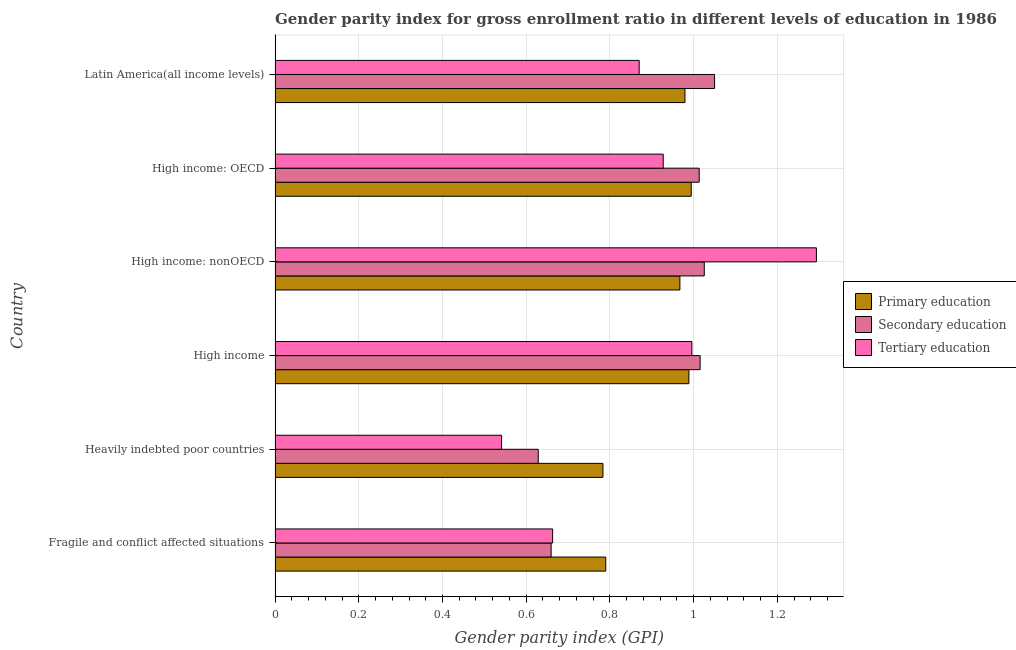How many different coloured bars are there?
Provide a short and direct response. 3. How many groups of bars are there?
Keep it short and to the point. 6. Are the number of bars on each tick of the Y-axis equal?
Offer a very short reply. Yes. What is the label of the 3rd group of bars from the top?
Make the answer very short. High income: nonOECD. What is the gender parity index in secondary education in High income: nonOECD?
Offer a very short reply. 1.03. Across all countries, what is the maximum gender parity index in primary education?
Your response must be concise. 0.99. Across all countries, what is the minimum gender parity index in secondary education?
Your answer should be compact. 0.63. In which country was the gender parity index in primary education maximum?
Make the answer very short. High income: OECD. In which country was the gender parity index in tertiary education minimum?
Offer a terse response. Heavily indebted poor countries. What is the total gender parity index in secondary education in the graph?
Your answer should be very brief. 5.39. What is the difference between the gender parity index in secondary education in High income and that in High income: OECD?
Your answer should be very brief. 0. What is the difference between the gender parity index in secondary education in High income and the gender parity index in primary education in Fragile and conflict affected situations?
Provide a short and direct response. 0.23. What is the average gender parity index in tertiary education per country?
Your response must be concise. 0.88. What is the difference between the gender parity index in secondary education and gender parity index in primary education in High income: OECD?
Offer a very short reply. 0.02. What is the ratio of the gender parity index in tertiary education in High income: OECD to that in High income: nonOECD?
Provide a short and direct response. 0.72. Is the difference between the gender parity index in primary education in High income: OECD and High income: nonOECD greater than the difference between the gender parity index in secondary education in High income: OECD and High income: nonOECD?
Offer a terse response. Yes. What is the difference between the highest and the second highest gender parity index in primary education?
Give a very brief answer. 0.01. What is the difference between the highest and the lowest gender parity index in tertiary education?
Your answer should be compact. 0.75. Is the sum of the gender parity index in primary education in Fragile and conflict affected situations and Heavily indebted poor countries greater than the maximum gender parity index in tertiary education across all countries?
Give a very brief answer. Yes. What does the 1st bar from the top in Heavily indebted poor countries represents?
Your answer should be compact. Tertiary education. What does the 3rd bar from the bottom in High income represents?
Offer a very short reply. Tertiary education. Is it the case that in every country, the sum of the gender parity index in primary education and gender parity index in secondary education is greater than the gender parity index in tertiary education?
Provide a succinct answer. Yes. How many bars are there?
Provide a short and direct response. 18. How many countries are there in the graph?
Keep it short and to the point. 6. What is the difference between two consecutive major ticks on the X-axis?
Your response must be concise. 0.2. Are the values on the major ticks of X-axis written in scientific E-notation?
Make the answer very short. No. Does the graph contain any zero values?
Provide a short and direct response. No. Where does the legend appear in the graph?
Provide a succinct answer. Center right. What is the title of the graph?
Provide a succinct answer. Gender parity index for gross enrollment ratio in different levels of education in 1986. Does "Ages 0-14" appear as one of the legend labels in the graph?
Your response must be concise. No. What is the label or title of the X-axis?
Make the answer very short. Gender parity index (GPI). What is the label or title of the Y-axis?
Your answer should be compact. Country. What is the Gender parity index (GPI) of Primary education in Fragile and conflict affected situations?
Offer a very short reply. 0.79. What is the Gender parity index (GPI) of Secondary education in Fragile and conflict affected situations?
Make the answer very short. 0.66. What is the Gender parity index (GPI) in Tertiary education in Fragile and conflict affected situations?
Offer a very short reply. 0.66. What is the Gender parity index (GPI) of Primary education in Heavily indebted poor countries?
Offer a terse response. 0.78. What is the Gender parity index (GPI) of Secondary education in Heavily indebted poor countries?
Give a very brief answer. 0.63. What is the Gender parity index (GPI) in Tertiary education in Heavily indebted poor countries?
Offer a very short reply. 0.54. What is the Gender parity index (GPI) of Primary education in High income?
Make the answer very short. 0.99. What is the Gender parity index (GPI) in Secondary education in High income?
Offer a very short reply. 1.02. What is the Gender parity index (GPI) in Tertiary education in High income?
Offer a very short reply. 1. What is the Gender parity index (GPI) of Primary education in High income: nonOECD?
Provide a short and direct response. 0.97. What is the Gender parity index (GPI) of Secondary education in High income: nonOECD?
Ensure brevity in your answer.  1.03. What is the Gender parity index (GPI) of Tertiary education in High income: nonOECD?
Keep it short and to the point. 1.29. What is the Gender parity index (GPI) in Primary education in High income: OECD?
Your answer should be compact. 0.99. What is the Gender parity index (GPI) of Secondary education in High income: OECD?
Provide a succinct answer. 1.01. What is the Gender parity index (GPI) in Tertiary education in High income: OECD?
Your response must be concise. 0.93. What is the Gender parity index (GPI) of Primary education in Latin America(all income levels)?
Provide a succinct answer. 0.98. What is the Gender parity index (GPI) in Secondary education in Latin America(all income levels)?
Keep it short and to the point. 1.05. What is the Gender parity index (GPI) in Tertiary education in Latin America(all income levels)?
Provide a succinct answer. 0.87. Across all countries, what is the maximum Gender parity index (GPI) of Primary education?
Your response must be concise. 0.99. Across all countries, what is the maximum Gender parity index (GPI) of Secondary education?
Make the answer very short. 1.05. Across all countries, what is the maximum Gender parity index (GPI) in Tertiary education?
Your answer should be very brief. 1.29. Across all countries, what is the minimum Gender parity index (GPI) in Primary education?
Make the answer very short. 0.78. Across all countries, what is the minimum Gender parity index (GPI) of Secondary education?
Keep it short and to the point. 0.63. Across all countries, what is the minimum Gender parity index (GPI) in Tertiary education?
Your answer should be compact. 0.54. What is the total Gender parity index (GPI) in Primary education in the graph?
Offer a terse response. 5.5. What is the total Gender parity index (GPI) in Secondary education in the graph?
Offer a terse response. 5.39. What is the total Gender parity index (GPI) in Tertiary education in the graph?
Your response must be concise. 5.29. What is the difference between the Gender parity index (GPI) in Primary education in Fragile and conflict affected situations and that in Heavily indebted poor countries?
Offer a very short reply. 0.01. What is the difference between the Gender parity index (GPI) in Secondary education in Fragile and conflict affected situations and that in Heavily indebted poor countries?
Offer a very short reply. 0.03. What is the difference between the Gender parity index (GPI) in Tertiary education in Fragile and conflict affected situations and that in Heavily indebted poor countries?
Provide a short and direct response. 0.12. What is the difference between the Gender parity index (GPI) of Primary education in Fragile and conflict affected situations and that in High income?
Your answer should be compact. -0.2. What is the difference between the Gender parity index (GPI) of Secondary education in Fragile and conflict affected situations and that in High income?
Your answer should be very brief. -0.36. What is the difference between the Gender parity index (GPI) in Tertiary education in Fragile and conflict affected situations and that in High income?
Your answer should be compact. -0.33. What is the difference between the Gender parity index (GPI) in Primary education in Fragile and conflict affected situations and that in High income: nonOECD?
Ensure brevity in your answer.  -0.18. What is the difference between the Gender parity index (GPI) in Secondary education in Fragile and conflict affected situations and that in High income: nonOECD?
Keep it short and to the point. -0.37. What is the difference between the Gender parity index (GPI) in Tertiary education in Fragile and conflict affected situations and that in High income: nonOECD?
Your answer should be compact. -0.63. What is the difference between the Gender parity index (GPI) in Primary education in Fragile and conflict affected situations and that in High income: OECD?
Your answer should be very brief. -0.2. What is the difference between the Gender parity index (GPI) in Secondary education in Fragile and conflict affected situations and that in High income: OECD?
Provide a succinct answer. -0.35. What is the difference between the Gender parity index (GPI) of Tertiary education in Fragile and conflict affected situations and that in High income: OECD?
Provide a succinct answer. -0.26. What is the difference between the Gender parity index (GPI) of Primary education in Fragile and conflict affected situations and that in Latin America(all income levels)?
Keep it short and to the point. -0.19. What is the difference between the Gender parity index (GPI) in Secondary education in Fragile and conflict affected situations and that in Latin America(all income levels)?
Offer a very short reply. -0.39. What is the difference between the Gender parity index (GPI) of Tertiary education in Fragile and conflict affected situations and that in Latin America(all income levels)?
Ensure brevity in your answer.  -0.21. What is the difference between the Gender parity index (GPI) of Primary education in Heavily indebted poor countries and that in High income?
Ensure brevity in your answer.  -0.21. What is the difference between the Gender parity index (GPI) in Secondary education in Heavily indebted poor countries and that in High income?
Provide a succinct answer. -0.39. What is the difference between the Gender parity index (GPI) of Tertiary education in Heavily indebted poor countries and that in High income?
Provide a short and direct response. -0.45. What is the difference between the Gender parity index (GPI) of Primary education in Heavily indebted poor countries and that in High income: nonOECD?
Your answer should be compact. -0.18. What is the difference between the Gender parity index (GPI) of Secondary education in Heavily indebted poor countries and that in High income: nonOECD?
Your answer should be compact. -0.4. What is the difference between the Gender parity index (GPI) of Tertiary education in Heavily indebted poor countries and that in High income: nonOECD?
Your answer should be compact. -0.75. What is the difference between the Gender parity index (GPI) in Primary education in Heavily indebted poor countries and that in High income: OECD?
Offer a terse response. -0.21. What is the difference between the Gender parity index (GPI) of Secondary education in Heavily indebted poor countries and that in High income: OECD?
Your response must be concise. -0.38. What is the difference between the Gender parity index (GPI) of Tertiary education in Heavily indebted poor countries and that in High income: OECD?
Make the answer very short. -0.39. What is the difference between the Gender parity index (GPI) in Primary education in Heavily indebted poor countries and that in Latin America(all income levels)?
Offer a very short reply. -0.2. What is the difference between the Gender parity index (GPI) of Secondary education in Heavily indebted poor countries and that in Latin America(all income levels)?
Ensure brevity in your answer.  -0.42. What is the difference between the Gender parity index (GPI) in Tertiary education in Heavily indebted poor countries and that in Latin America(all income levels)?
Give a very brief answer. -0.33. What is the difference between the Gender parity index (GPI) of Primary education in High income and that in High income: nonOECD?
Keep it short and to the point. 0.02. What is the difference between the Gender parity index (GPI) in Secondary education in High income and that in High income: nonOECD?
Your answer should be very brief. -0.01. What is the difference between the Gender parity index (GPI) of Tertiary education in High income and that in High income: nonOECD?
Your answer should be very brief. -0.3. What is the difference between the Gender parity index (GPI) of Primary education in High income and that in High income: OECD?
Offer a very short reply. -0.01. What is the difference between the Gender parity index (GPI) of Secondary education in High income and that in High income: OECD?
Your answer should be very brief. 0. What is the difference between the Gender parity index (GPI) of Tertiary education in High income and that in High income: OECD?
Offer a terse response. 0.07. What is the difference between the Gender parity index (GPI) of Primary education in High income and that in Latin America(all income levels)?
Provide a succinct answer. 0.01. What is the difference between the Gender parity index (GPI) of Secondary education in High income and that in Latin America(all income levels)?
Offer a very short reply. -0.03. What is the difference between the Gender parity index (GPI) in Tertiary education in High income and that in Latin America(all income levels)?
Give a very brief answer. 0.13. What is the difference between the Gender parity index (GPI) in Primary education in High income: nonOECD and that in High income: OECD?
Keep it short and to the point. -0.03. What is the difference between the Gender parity index (GPI) of Secondary education in High income: nonOECD and that in High income: OECD?
Provide a succinct answer. 0.01. What is the difference between the Gender parity index (GPI) in Tertiary education in High income: nonOECD and that in High income: OECD?
Provide a short and direct response. 0.37. What is the difference between the Gender parity index (GPI) in Primary education in High income: nonOECD and that in Latin America(all income levels)?
Provide a succinct answer. -0.01. What is the difference between the Gender parity index (GPI) in Secondary education in High income: nonOECD and that in Latin America(all income levels)?
Provide a short and direct response. -0.02. What is the difference between the Gender parity index (GPI) in Tertiary education in High income: nonOECD and that in Latin America(all income levels)?
Offer a terse response. 0.42. What is the difference between the Gender parity index (GPI) of Primary education in High income: OECD and that in Latin America(all income levels)?
Make the answer very short. 0.01. What is the difference between the Gender parity index (GPI) in Secondary education in High income: OECD and that in Latin America(all income levels)?
Offer a very short reply. -0.04. What is the difference between the Gender parity index (GPI) of Tertiary education in High income: OECD and that in Latin America(all income levels)?
Your answer should be very brief. 0.06. What is the difference between the Gender parity index (GPI) in Primary education in Fragile and conflict affected situations and the Gender parity index (GPI) in Secondary education in Heavily indebted poor countries?
Your response must be concise. 0.16. What is the difference between the Gender parity index (GPI) of Primary education in Fragile and conflict affected situations and the Gender parity index (GPI) of Tertiary education in Heavily indebted poor countries?
Give a very brief answer. 0.25. What is the difference between the Gender parity index (GPI) of Secondary education in Fragile and conflict affected situations and the Gender parity index (GPI) of Tertiary education in Heavily indebted poor countries?
Provide a short and direct response. 0.12. What is the difference between the Gender parity index (GPI) of Primary education in Fragile and conflict affected situations and the Gender parity index (GPI) of Secondary education in High income?
Give a very brief answer. -0.23. What is the difference between the Gender parity index (GPI) in Primary education in Fragile and conflict affected situations and the Gender parity index (GPI) in Tertiary education in High income?
Your response must be concise. -0.21. What is the difference between the Gender parity index (GPI) of Secondary education in Fragile and conflict affected situations and the Gender parity index (GPI) of Tertiary education in High income?
Provide a succinct answer. -0.34. What is the difference between the Gender parity index (GPI) in Primary education in Fragile and conflict affected situations and the Gender parity index (GPI) in Secondary education in High income: nonOECD?
Keep it short and to the point. -0.24. What is the difference between the Gender parity index (GPI) of Primary education in Fragile and conflict affected situations and the Gender parity index (GPI) of Tertiary education in High income: nonOECD?
Provide a short and direct response. -0.5. What is the difference between the Gender parity index (GPI) of Secondary education in Fragile and conflict affected situations and the Gender parity index (GPI) of Tertiary education in High income: nonOECD?
Make the answer very short. -0.63. What is the difference between the Gender parity index (GPI) of Primary education in Fragile and conflict affected situations and the Gender parity index (GPI) of Secondary education in High income: OECD?
Ensure brevity in your answer.  -0.22. What is the difference between the Gender parity index (GPI) in Primary education in Fragile and conflict affected situations and the Gender parity index (GPI) in Tertiary education in High income: OECD?
Your answer should be very brief. -0.14. What is the difference between the Gender parity index (GPI) of Secondary education in Fragile and conflict affected situations and the Gender parity index (GPI) of Tertiary education in High income: OECD?
Ensure brevity in your answer.  -0.27. What is the difference between the Gender parity index (GPI) in Primary education in Fragile and conflict affected situations and the Gender parity index (GPI) in Secondary education in Latin America(all income levels)?
Provide a short and direct response. -0.26. What is the difference between the Gender parity index (GPI) of Primary education in Fragile and conflict affected situations and the Gender parity index (GPI) of Tertiary education in Latin America(all income levels)?
Offer a very short reply. -0.08. What is the difference between the Gender parity index (GPI) in Secondary education in Fragile and conflict affected situations and the Gender parity index (GPI) in Tertiary education in Latin America(all income levels)?
Give a very brief answer. -0.21. What is the difference between the Gender parity index (GPI) of Primary education in Heavily indebted poor countries and the Gender parity index (GPI) of Secondary education in High income?
Make the answer very short. -0.23. What is the difference between the Gender parity index (GPI) of Primary education in Heavily indebted poor countries and the Gender parity index (GPI) of Tertiary education in High income?
Make the answer very short. -0.21. What is the difference between the Gender parity index (GPI) in Secondary education in Heavily indebted poor countries and the Gender parity index (GPI) in Tertiary education in High income?
Give a very brief answer. -0.37. What is the difference between the Gender parity index (GPI) of Primary education in Heavily indebted poor countries and the Gender parity index (GPI) of Secondary education in High income: nonOECD?
Make the answer very short. -0.24. What is the difference between the Gender parity index (GPI) in Primary education in Heavily indebted poor countries and the Gender parity index (GPI) in Tertiary education in High income: nonOECD?
Ensure brevity in your answer.  -0.51. What is the difference between the Gender parity index (GPI) of Secondary education in Heavily indebted poor countries and the Gender parity index (GPI) of Tertiary education in High income: nonOECD?
Ensure brevity in your answer.  -0.66. What is the difference between the Gender parity index (GPI) in Primary education in Heavily indebted poor countries and the Gender parity index (GPI) in Secondary education in High income: OECD?
Give a very brief answer. -0.23. What is the difference between the Gender parity index (GPI) of Primary education in Heavily indebted poor countries and the Gender parity index (GPI) of Tertiary education in High income: OECD?
Keep it short and to the point. -0.14. What is the difference between the Gender parity index (GPI) in Secondary education in Heavily indebted poor countries and the Gender parity index (GPI) in Tertiary education in High income: OECD?
Your answer should be compact. -0.3. What is the difference between the Gender parity index (GPI) of Primary education in Heavily indebted poor countries and the Gender parity index (GPI) of Secondary education in Latin America(all income levels)?
Give a very brief answer. -0.27. What is the difference between the Gender parity index (GPI) of Primary education in Heavily indebted poor countries and the Gender parity index (GPI) of Tertiary education in Latin America(all income levels)?
Your answer should be compact. -0.09. What is the difference between the Gender parity index (GPI) of Secondary education in Heavily indebted poor countries and the Gender parity index (GPI) of Tertiary education in Latin America(all income levels)?
Your response must be concise. -0.24. What is the difference between the Gender parity index (GPI) of Primary education in High income and the Gender parity index (GPI) of Secondary education in High income: nonOECD?
Provide a succinct answer. -0.04. What is the difference between the Gender parity index (GPI) of Primary education in High income and the Gender parity index (GPI) of Tertiary education in High income: nonOECD?
Your response must be concise. -0.3. What is the difference between the Gender parity index (GPI) in Secondary education in High income and the Gender parity index (GPI) in Tertiary education in High income: nonOECD?
Give a very brief answer. -0.28. What is the difference between the Gender parity index (GPI) of Primary education in High income and the Gender parity index (GPI) of Secondary education in High income: OECD?
Your answer should be compact. -0.02. What is the difference between the Gender parity index (GPI) of Primary education in High income and the Gender parity index (GPI) of Tertiary education in High income: OECD?
Your response must be concise. 0.06. What is the difference between the Gender parity index (GPI) of Secondary education in High income and the Gender parity index (GPI) of Tertiary education in High income: OECD?
Your response must be concise. 0.09. What is the difference between the Gender parity index (GPI) of Primary education in High income and the Gender parity index (GPI) of Secondary education in Latin America(all income levels)?
Provide a short and direct response. -0.06. What is the difference between the Gender parity index (GPI) in Primary education in High income and the Gender parity index (GPI) in Tertiary education in Latin America(all income levels)?
Give a very brief answer. 0.12. What is the difference between the Gender parity index (GPI) of Secondary education in High income and the Gender parity index (GPI) of Tertiary education in Latin America(all income levels)?
Offer a terse response. 0.15. What is the difference between the Gender parity index (GPI) of Primary education in High income: nonOECD and the Gender parity index (GPI) of Secondary education in High income: OECD?
Ensure brevity in your answer.  -0.05. What is the difference between the Gender parity index (GPI) of Primary education in High income: nonOECD and the Gender parity index (GPI) of Tertiary education in High income: OECD?
Ensure brevity in your answer.  0.04. What is the difference between the Gender parity index (GPI) of Secondary education in High income: nonOECD and the Gender parity index (GPI) of Tertiary education in High income: OECD?
Ensure brevity in your answer.  0.1. What is the difference between the Gender parity index (GPI) in Primary education in High income: nonOECD and the Gender parity index (GPI) in Secondary education in Latin America(all income levels)?
Provide a short and direct response. -0.08. What is the difference between the Gender parity index (GPI) in Primary education in High income: nonOECD and the Gender parity index (GPI) in Tertiary education in Latin America(all income levels)?
Keep it short and to the point. 0.1. What is the difference between the Gender parity index (GPI) of Secondary education in High income: nonOECD and the Gender parity index (GPI) of Tertiary education in Latin America(all income levels)?
Ensure brevity in your answer.  0.16. What is the difference between the Gender parity index (GPI) in Primary education in High income: OECD and the Gender parity index (GPI) in Secondary education in Latin America(all income levels)?
Keep it short and to the point. -0.06. What is the difference between the Gender parity index (GPI) in Primary education in High income: OECD and the Gender parity index (GPI) in Tertiary education in Latin America(all income levels)?
Provide a short and direct response. 0.12. What is the difference between the Gender parity index (GPI) of Secondary education in High income: OECD and the Gender parity index (GPI) of Tertiary education in Latin America(all income levels)?
Make the answer very short. 0.14. What is the average Gender parity index (GPI) in Primary education per country?
Your answer should be very brief. 0.92. What is the average Gender parity index (GPI) of Secondary education per country?
Provide a short and direct response. 0.9. What is the average Gender parity index (GPI) of Tertiary education per country?
Keep it short and to the point. 0.88. What is the difference between the Gender parity index (GPI) of Primary education and Gender parity index (GPI) of Secondary education in Fragile and conflict affected situations?
Make the answer very short. 0.13. What is the difference between the Gender parity index (GPI) in Primary education and Gender parity index (GPI) in Tertiary education in Fragile and conflict affected situations?
Your answer should be very brief. 0.13. What is the difference between the Gender parity index (GPI) of Secondary education and Gender parity index (GPI) of Tertiary education in Fragile and conflict affected situations?
Keep it short and to the point. -0. What is the difference between the Gender parity index (GPI) of Primary education and Gender parity index (GPI) of Secondary education in Heavily indebted poor countries?
Your answer should be compact. 0.15. What is the difference between the Gender parity index (GPI) of Primary education and Gender parity index (GPI) of Tertiary education in Heavily indebted poor countries?
Make the answer very short. 0.24. What is the difference between the Gender parity index (GPI) of Secondary education and Gender parity index (GPI) of Tertiary education in Heavily indebted poor countries?
Offer a terse response. 0.09. What is the difference between the Gender parity index (GPI) of Primary education and Gender parity index (GPI) of Secondary education in High income?
Make the answer very short. -0.03. What is the difference between the Gender parity index (GPI) of Primary education and Gender parity index (GPI) of Tertiary education in High income?
Provide a short and direct response. -0.01. What is the difference between the Gender parity index (GPI) in Secondary education and Gender parity index (GPI) in Tertiary education in High income?
Your answer should be very brief. 0.02. What is the difference between the Gender parity index (GPI) of Primary education and Gender parity index (GPI) of Secondary education in High income: nonOECD?
Your answer should be compact. -0.06. What is the difference between the Gender parity index (GPI) of Primary education and Gender parity index (GPI) of Tertiary education in High income: nonOECD?
Give a very brief answer. -0.33. What is the difference between the Gender parity index (GPI) of Secondary education and Gender parity index (GPI) of Tertiary education in High income: nonOECD?
Give a very brief answer. -0.27. What is the difference between the Gender parity index (GPI) of Primary education and Gender parity index (GPI) of Secondary education in High income: OECD?
Offer a very short reply. -0.02. What is the difference between the Gender parity index (GPI) of Primary education and Gender parity index (GPI) of Tertiary education in High income: OECD?
Ensure brevity in your answer.  0.07. What is the difference between the Gender parity index (GPI) of Secondary education and Gender parity index (GPI) of Tertiary education in High income: OECD?
Make the answer very short. 0.09. What is the difference between the Gender parity index (GPI) in Primary education and Gender parity index (GPI) in Secondary education in Latin America(all income levels)?
Give a very brief answer. -0.07. What is the difference between the Gender parity index (GPI) in Primary education and Gender parity index (GPI) in Tertiary education in Latin America(all income levels)?
Give a very brief answer. 0.11. What is the difference between the Gender parity index (GPI) in Secondary education and Gender parity index (GPI) in Tertiary education in Latin America(all income levels)?
Offer a terse response. 0.18. What is the ratio of the Gender parity index (GPI) in Primary education in Fragile and conflict affected situations to that in Heavily indebted poor countries?
Provide a short and direct response. 1.01. What is the ratio of the Gender parity index (GPI) in Secondary education in Fragile and conflict affected situations to that in Heavily indebted poor countries?
Give a very brief answer. 1.05. What is the ratio of the Gender parity index (GPI) in Tertiary education in Fragile and conflict affected situations to that in Heavily indebted poor countries?
Give a very brief answer. 1.23. What is the ratio of the Gender parity index (GPI) in Primary education in Fragile and conflict affected situations to that in High income?
Offer a terse response. 0.8. What is the ratio of the Gender parity index (GPI) of Secondary education in Fragile and conflict affected situations to that in High income?
Your answer should be very brief. 0.65. What is the ratio of the Gender parity index (GPI) in Tertiary education in Fragile and conflict affected situations to that in High income?
Make the answer very short. 0.67. What is the ratio of the Gender parity index (GPI) in Primary education in Fragile and conflict affected situations to that in High income: nonOECD?
Your answer should be compact. 0.82. What is the ratio of the Gender parity index (GPI) in Secondary education in Fragile and conflict affected situations to that in High income: nonOECD?
Provide a succinct answer. 0.64. What is the ratio of the Gender parity index (GPI) in Tertiary education in Fragile and conflict affected situations to that in High income: nonOECD?
Offer a very short reply. 0.51. What is the ratio of the Gender parity index (GPI) of Primary education in Fragile and conflict affected situations to that in High income: OECD?
Make the answer very short. 0.79. What is the ratio of the Gender parity index (GPI) in Secondary education in Fragile and conflict affected situations to that in High income: OECD?
Offer a very short reply. 0.65. What is the ratio of the Gender parity index (GPI) in Tertiary education in Fragile and conflict affected situations to that in High income: OECD?
Provide a short and direct response. 0.71. What is the ratio of the Gender parity index (GPI) of Primary education in Fragile and conflict affected situations to that in Latin America(all income levels)?
Provide a succinct answer. 0.81. What is the ratio of the Gender parity index (GPI) of Secondary education in Fragile and conflict affected situations to that in Latin America(all income levels)?
Provide a succinct answer. 0.63. What is the ratio of the Gender parity index (GPI) in Tertiary education in Fragile and conflict affected situations to that in Latin America(all income levels)?
Your response must be concise. 0.76. What is the ratio of the Gender parity index (GPI) of Primary education in Heavily indebted poor countries to that in High income?
Provide a succinct answer. 0.79. What is the ratio of the Gender parity index (GPI) in Secondary education in Heavily indebted poor countries to that in High income?
Offer a terse response. 0.62. What is the ratio of the Gender parity index (GPI) in Tertiary education in Heavily indebted poor countries to that in High income?
Your answer should be very brief. 0.54. What is the ratio of the Gender parity index (GPI) in Primary education in Heavily indebted poor countries to that in High income: nonOECD?
Provide a succinct answer. 0.81. What is the ratio of the Gender parity index (GPI) in Secondary education in Heavily indebted poor countries to that in High income: nonOECD?
Make the answer very short. 0.61. What is the ratio of the Gender parity index (GPI) in Tertiary education in Heavily indebted poor countries to that in High income: nonOECD?
Your response must be concise. 0.42. What is the ratio of the Gender parity index (GPI) of Primary education in Heavily indebted poor countries to that in High income: OECD?
Give a very brief answer. 0.79. What is the ratio of the Gender parity index (GPI) of Secondary education in Heavily indebted poor countries to that in High income: OECD?
Provide a succinct answer. 0.62. What is the ratio of the Gender parity index (GPI) of Tertiary education in Heavily indebted poor countries to that in High income: OECD?
Give a very brief answer. 0.58. What is the ratio of the Gender parity index (GPI) in Primary education in Heavily indebted poor countries to that in Latin America(all income levels)?
Provide a succinct answer. 0.8. What is the ratio of the Gender parity index (GPI) in Secondary education in Heavily indebted poor countries to that in Latin America(all income levels)?
Provide a short and direct response. 0.6. What is the ratio of the Gender parity index (GPI) in Tertiary education in Heavily indebted poor countries to that in Latin America(all income levels)?
Provide a short and direct response. 0.62. What is the ratio of the Gender parity index (GPI) in Primary education in High income to that in High income: nonOECD?
Keep it short and to the point. 1.02. What is the ratio of the Gender parity index (GPI) of Secondary education in High income to that in High income: nonOECD?
Keep it short and to the point. 0.99. What is the ratio of the Gender parity index (GPI) in Tertiary education in High income to that in High income: nonOECD?
Give a very brief answer. 0.77. What is the ratio of the Gender parity index (GPI) of Secondary education in High income to that in High income: OECD?
Provide a succinct answer. 1. What is the ratio of the Gender parity index (GPI) in Tertiary education in High income to that in High income: OECD?
Provide a short and direct response. 1.07. What is the ratio of the Gender parity index (GPI) of Primary education in High income to that in Latin America(all income levels)?
Keep it short and to the point. 1.01. What is the ratio of the Gender parity index (GPI) in Secondary education in High income to that in Latin America(all income levels)?
Your response must be concise. 0.97. What is the ratio of the Gender parity index (GPI) in Tertiary education in High income to that in Latin America(all income levels)?
Offer a very short reply. 1.14. What is the ratio of the Gender parity index (GPI) of Primary education in High income: nonOECD to that in High income: OECD?
Ensure brevity in your answer.  0.97. What is the ratio of the Gender parity index (GPI) of Tertiary education in High income: nonOECD to that in High income: OECD?
Provide a short and direct response. 1.39. What is the ratio of the Gender parity index (GPI) in Primary education in High income: nonOECD to that in Latin America(all income levels)?
Provide a succinct answer. 0.99. What is the ratio of the Gender parity index (GPI) in Secondary education in High income: nonOECD to that in Latin America(all income levels)?
Your answer should be very brief. 0.98. What is the ratio of the Gender parity index (GPI) of Tertiary education in High income: nonOECD to that in Latin America(all income levels)?
Offer a terse response. 1.49. What is the ratio of the Gender parity index (GPI) of Primary education in High income: OECD to that in Latin America(all income levels)?
Offer a terse response. 1.02. What is the ratio of the Gender parity index (GPI) in Secondary education in High income: OECD to that in Latin America(all income levels)?
Make the answer very short. 0.97. What is the ratio of the Gender parity index (GPI) in Tertiary education in High income: OECD to that in Latin America(all income levels)?
Your answer should be compact. 1.07. What is the difference between the highest and the second highest Gender parity index (GPI) in Primary education?
Ensure brevity in your answer.  0.01. What is the difference between the highest and the second highest Gender parity index (GPI) in Secondary education?
Provide a short and direct response. 0.02. What is the difference between the highest and the second highest Gender parity index (GPI) of Tertiary education?
Make the answer very short. 0.3. What is the difference between the highest and the lowest Gender parity index (GPI) of Primary education?
Keep it short and to the point. 0.21. What is the difference between the highest and the lowest Gender parity index (GPI) of Secondary education?
Keep it short and to the point. 0.42. What is the difference between the highest and the lowest Gender parity index (GPI) in Tertiary education?
Give a very brief answer. 0.75. 